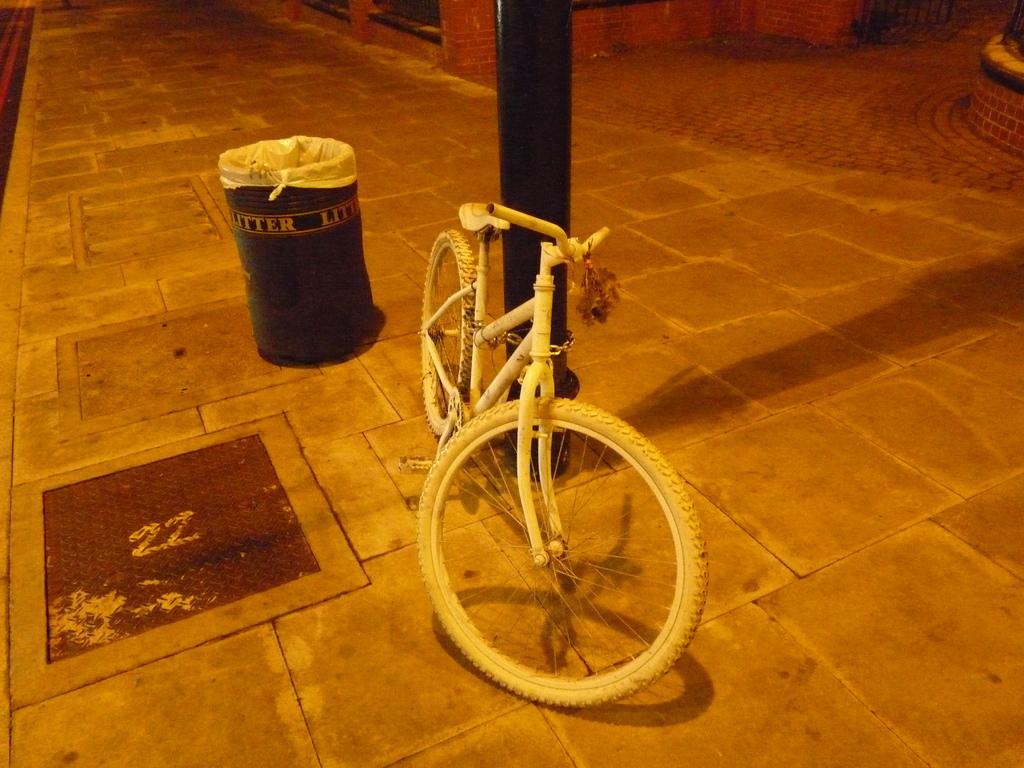Please provide a concise description of this image. In this image we can see a bicycle and a dustbin on the footpath at the pole and there is a metal door on the footpath and we can see objects. 